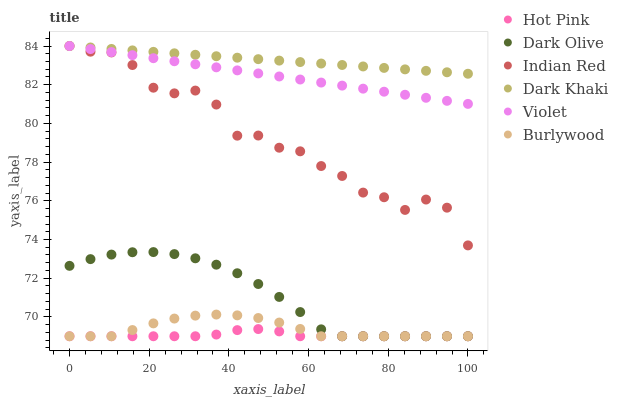Does Hot Pink have the minimum area under the curve?
Answer yes or no. Yes. Does Dark Khaki have the maximum area under the curve?
Answer yes or no. Yes. Does Burlywood have the minimum area under the curve?
Answer yes or no. No. Does Burlywood have the maximum area under the curve?
Answer yes or no. No. Is Violet the smoothest?
Answer yes or no. Yes. Is Indian Red the roughest?
Answer yes or no. Yes. Is Burlywood the smoothest?
Answer yes or no. No. Is Burlywood the roughest?
Answer yes or no. No. Does Hot Pink have the lowest value?
Answer yes or no. Yes. Does Dark Khaki have the lowest value?
Answer yes or no. No. Does Violet have the highest value?
Answer yes or no. Yes. Does Burlywood have the highest value?
Answer yes or no. No. Is Hot Pink less than Dark Khaki?
Answer yes or no. Yes. Is Violet greater than Hot Pink?
Answer yes or no. Yes. Does Hot Pink intersect Dark Olive?
Answer yes or no. Yes. Is Hot Pink less than Dark Olive?
Answer yes or no. No. Is Hot Pink greater than Dark Olive?
Answer yes or no. No. Does Hot Pink intersect Dark Khaki?
Answer yes or no. No. 